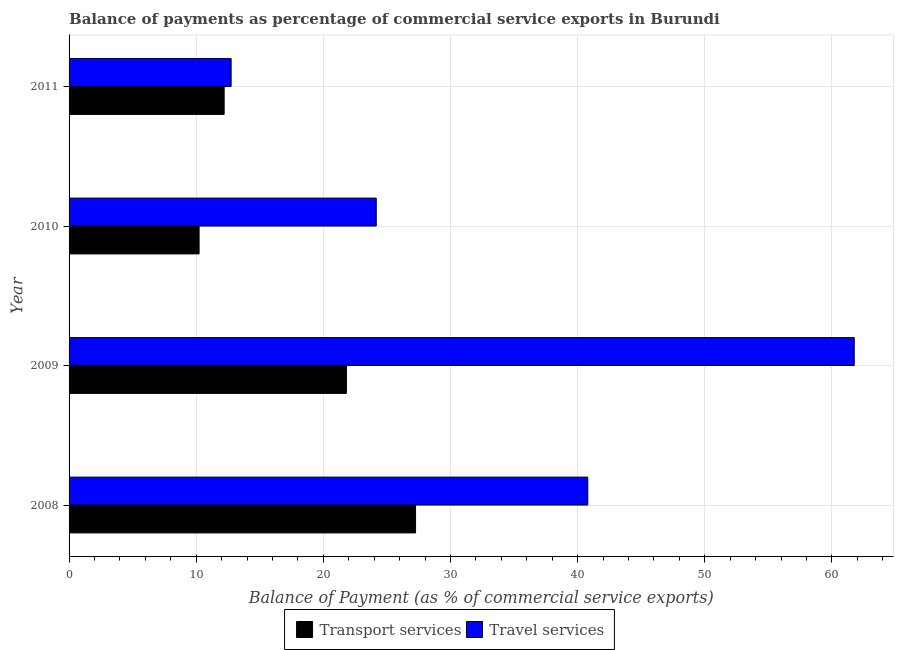How many different coloured bars are there?
Your response must be concise. 2. How many groups of bars are there?
Make the answer very short. 4. Are the number of bars per tick equal to the number of legend labels?
Provide a succinct answer. Yes. Are the number of bars on each tick of the Y-axis equal?
Provide a succinct answer. Yes. What is the label of the 3rd group of bars from the top?
Keep it short and to the point. 2009. In how many cases, is the number of bars for a given year not equal to the number of legend labels?
Your answer should be compact. 0. What is the balance of payments of transport services in 2011?
Provide a short and direct response. 12.2. Across all years, what is the maximum balance of payments of transport services?
Keep it short and to the point. 27.26. Across all years, what is the minimum balance of payments of travel services?
Ensure brevity in your answer.  12.75. In which year was the balance of payments of travel services maximum?
Keep it short and to the point. 2009. In which year was the balance of payments of travel services minimum?
Offer a very short reply. 2011. What is the total balance of payments of travel services in the graph?
Offer a very short reply. 139.47. What is the difference between the balance of payments of transport services in 2008 and that in 2011?
Make the answer very short. 15.06. What is the difference between the balance of payments of travel services in 2011 and the balance of payments of transport services in 2009?
Provide a succinct answer. -9.07. What is the average balance of payments of transport services per year?
Provide a short and direct response. 17.87. In the year 2008, what is the difference between the balance of payments of transport services and balance of payments of travel services?
Your answer should be very brief. -13.54. What is the ratio of the balance of payments of transport services in 2009 to that in 2010?
Provide a short and direct response. 2.13. Is the balance of payments of travel services in 2008 less than that in 2009?
Keep it short and to the point. Yes. Is the difference between the balance of payments of travel services in 2008 and 2011 greater than the difference between the balance of payments of transport services in 2008 and 2011?
Provide a succinct answer. Yes. What is the difference between the highest and the second highest balance of payments of transport services?
Give a very brief answer. 5.44. What is the difference between the highest and the lowest balance of payments of travel services?
Offer a very short reply. 49.01. In how many years, is the balance of payments of transport services greater than the average balance of payments of transport services taken over all years?
Offer a very short reply. 2. Is the sum of the balance of payments of transport services in 2008 and 2010 greater than the maximum balance of payments of travel services across all years?
Your answer should be very brief. No. What does the 1st bar from the top in 2011 represents?
Provide a short and direct response. Travel services. What does the 1st bar from the bottom in 2011 represents?
Make the answer very short. Transport services. How many bars are there?
Your response must be concise. 8. Does the graph contain any zero values?
Keep it short and to the point. No. What is the title of the graph?
Make the answer very short. Balance of payments as percentage of commercial service exports in Burundi. Does "Mobile cellular" appear as one of the legend labels in the graph?
Keep it short and to the point. No. What is the label or title of the X-axis?
Offer a terse response. Balance of Payment (as % of commercial service exports). What is the Balance of Payment (as % of commercial service exports) in Transport services in 2008?
Offer a very short reply. 27.26. What is the Balance of Payment (as % of commercial service exports) of Travel services in 2008?
Keep it short and to the point. 40.8. What is the Balance of Payment (as % of commercial service exports) in Transport services in 2009?
Provide a short and direct response. 21.82. What is the Balance of Payment (as % of commercial service exports) of Travel services in 2009?
Provide a short and direct response. 61.76. What is the Balance of Payment (as % of commercial service exports) of Transport services in 2010?
Offer a terse response. 10.23. What is the Balance of Payment (as % of commercial service exports) of Travel services in 2010?
Your response must be concise. 24.16. What is the Balance of Payment (as % of commercial service exports) of Transport services in 2011?
Your answer should be compact. 12.2. What is the Balance of Payment (as % of commercial service exports) in Travel services in 2011?
Your response must be concise. 12.75. Across all years, what is the maximum Balance of Payment (as % of commercial service exports) of Transport services?
Your answer should be compact. 27.26. Across all years, what is the maximum Balance of Payment (as % of commercial service exports) of Travel services?
Your answer should be very brief. 61.76. Across all years, what is the minimum Balance of Payment (as % of commercial service exports) in Transport services?
Ensure brevity in your answer.  10.23. Across all years, what is the minimum Balance of Payment (as % of commercial service exports) of Travel services?
Offer a very short reply. 12.75. What is the total Balance of Payment (as % of commercial service exports) of Transport services in the graph?
Give a very brief answer. 71.5. What is the total Balance of Payment (as % of commercial service exports) in Travel services in the graph?
Make the answer very short. 139.47. What is the difference between the Balance of Payment (as % of commercial service exports) in Transport services in 2008 and that in 2009?
Your response must be concise. 5.44. What is the difference between the Balance of Payment (as % of commercial service exports) in Travel services in 2008 and that in 2009?
Give a very brief answer. -20.96. What is the difference between the Balance of Payment (as % of commercial service exports) of Transport services in 2008 and that in 2010?
Offer a very short reply. 17.03. What is the difference between the Balance of Payment (as % of commercial service exports) of Travel services in 2008 and that in 2010?
Make the answer very short. 16.64. What is the difference between the Balance of Payment (as % of commercial service exports) in Transport services in 2008 and that in 2011?
Provide a short and direct response. 15.06. What is the difference between the Balance of Payment (as % of commercial service exports) in Travel services in 2008 and that in 2011?
Your answer should be compact. 28.05. What is the difference between the Balance of Payment (as % of commercial service exports) in Transport services in 2009 and that in 2010?
Your answer should be compact. 11.59. What is the difference between the Balance of Payment (as % of commercial service exports) in Travel services in 2009 and that in 2010?
Provide a succinct answer. 37.6. What is the difference between the Balance of Payment (as % of commercial service exports) of Transport services in 2009 and that in 2011?
Offer a terse response. 9.62. What is the difference between the Balance of Payment (as % of commercial service exports) in Travel services in 2009 and that in 2011?
Provide a short and direct response. 49.01. What is the difference between the Balance of Payment (as % of commercial service exports) in Transport services in 2010 and that in 2011?
Offer a terse response. -1.97. What is the difference between the Balance of Payment (as % of commercial service exports) in Travel services in 2010 and that in 2011?
Give a very brief answer. 11.42. What is the difference between the Balance of Payment (as % of commercial service exports) of Transport services in 2008 and the Balance of Payment (as % of commercial service exports) of Travel services in 2009?
Provide a short and direct response. -34.51. What is the difference between the Balance of Payment (as % of commercial service exports) of Transport services in 2008 and the Balance of Payment (as % of commercial service exports) of Travel services in 2010?
Your response must be concise. 3.09. What is the difference between the Balance of Payment (as % of commercial service exports) of Transport services in 2008 and the Balance of Payment (as % of commercial service exports) of Travel services in 2011?
Your response must be concise. 14.51. What is the difference between the Balance of Payment (as % of commercial service exports) in Transport services in 2009 and the Balance of Payment (as % of commercial service exports) in Travel services in 2010?
Your answer should be very brief. -2.35. What is the difference between the Balance of Payment (as % of commercial service exports) in Transport services in 2009 and the Balance of Payment (as % of commercial service exports) in Travel services in 2011?
Give a very brief answer. 9.07. What is the difference between the Balance of Payment (as % of commercial service exports) in Transport services in 2010 and the Balance of Payment (as % of commercial service exports) in Travel services in 2011?
Ensure brevity in your answer.  -2.52. What is the average Balance of Payment (as % of commercial service exports) of Transport services per year?
Make the answer very short. 17.87. What is the average Balance of Payment (as % of commercial service exports) of Travel services per year?
Your answer should be very brief. 34.87. In the year 2008, what is the difference between the Balance of Payment (as % of commercial service exports) of Transport services and Balance of Payment (as % of commercial service exports) of Travel services?
Provide a short and direct response. -13.54. In the year 2009, what is the difference between the Balance of Payment (as % of commercial service exports) in Transport services and Balance of Payment (as % of commercial service exports) in Travel services?
Ensure brevity in your answer.  -39.94. In the year 2010, what is the difference between the Balance of Payment (as % of commercial service exports) in Transport services and Balance of Payment (as % of commercial service exports) in Travel services?
Offer a very short reply. -13.93. In the year 2011, what is the difference between the Balance of Payment (as % of commercial service exports) of Transport services and Balance of Payment (as % of commercial service exports) of Travel services?
Your answer should be very brief. -0.55. What is the ratio of the Balance of Payment (as % of commercial service exports) in Transport services in 2008 to that in 2009?
Offer a terse response. 1.25. What is the ratio of the Balance of Payment (as % of commercial service exports) in Travel services in 2008 to that in 2009?
Offer a terse response. 0.66. What is the ratio of the Balance of Payment (as % of commercial service exports) in Transport services in 2008 to that in 2010?
Provide a succinct answer. 2.66. What is the ratio of the Balance of Payment (as % of commercial service exports) of Travel services in 2008 to that in 2010?
Offer a very short reply. 1.69. What is the ratio of the Balance of Payment (as % of commercial service exports) in Transport services in 2008 to that in 2011?
Provide a succinct answer. 2.23. What is the ratio of the Balance of Payment (as % of commercial service exports) in Travel services in 2008 to that in 2011?
Ensure brevity in your answer.  3.2. What is the ratio of the Balance of Payment (as % of commercial service exports) in Transport services in 2009 to that in 2010?
Offer a very short reply. 2.13. What is the ratio of the Balance of Payment (as % of commercial service exports) of Travel services in 2009 to that in 2010?
Provide a succinct answer. 2.56. What is the ratio of the Balance of Payment (as % of commercial service exports) in Transport services in 2009 to that in 2011?
Keep it short and to the point. 1.79. What is the ratio of the Balance of Payment (as % of commercial service exports) of Travel services in 2009 to that in 2011?
Make the answer very short. 4.85. What is the ratio of the Balance of Payment (as % of commercial service exports) of Transport services in 2010 to that in 2011?
Keep it short and to the point. 0.84. What is the ratio of the Balance of Payment (as % of commercial service exports) in Travel services in 2010 to that in 2011?
Provide a short and direct response. 1.9. What is the difference between the highest and the second highest Balance of Payment (as % of commercial service exports) of Transport services?
Provide a short and direct response. 5.44. What is the difference between the highest and the second highest Balance of Payment (as % of commercial service exports) of Travel services?
Make the answer very short. 20.96. What is the difference between the highest and the lowest Balance of Payment (as % of commercial service exports) in Transport services?
Provide a short and direct response. 17.03. What is the difference between the highest and the lowest Balance of Payment (as % of commercial service exports) in Travel services?
Provide a succinct answer. 49.01. 